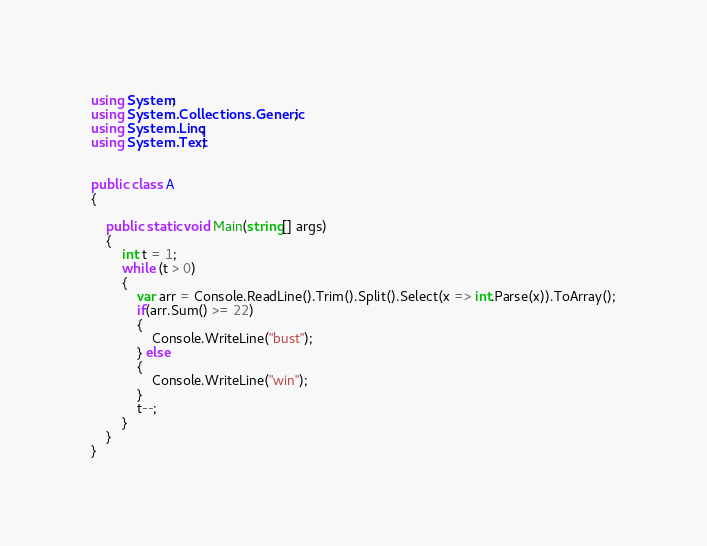Convert code to text. <code><loc_0><loc_0><loc_500><loc_500><_C#_>using System;
using System.Collections.Generic;
using System.Linq;
using System.Text;


public class A
{
  
    public static void Main(string[] args)
    {
        int t = 1;
        while (t > 0)
        {
            var arr = Console.ReadLine().Trim().Split().Select(x => int.Parse(x)).ToArray();
            if(arr.Sum() >= 22)
            {
                Console.WriteLine("bust");
            } else
            {
                Console.WriteLine("win");
            } 
            t--;
        }
    }
}</code> 